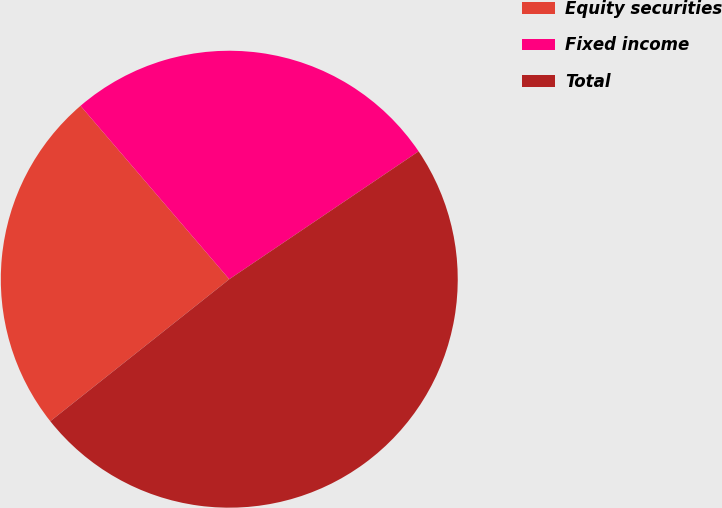<chart> <loc_0><loc_0><loc_500><loc_500><pie_chart><fcel>Equity securities<fcel>Fixed income<fcel>Total<nl><fcel>24.39%<fcel>26.83%<fcel>48.78%<nl></chart> 